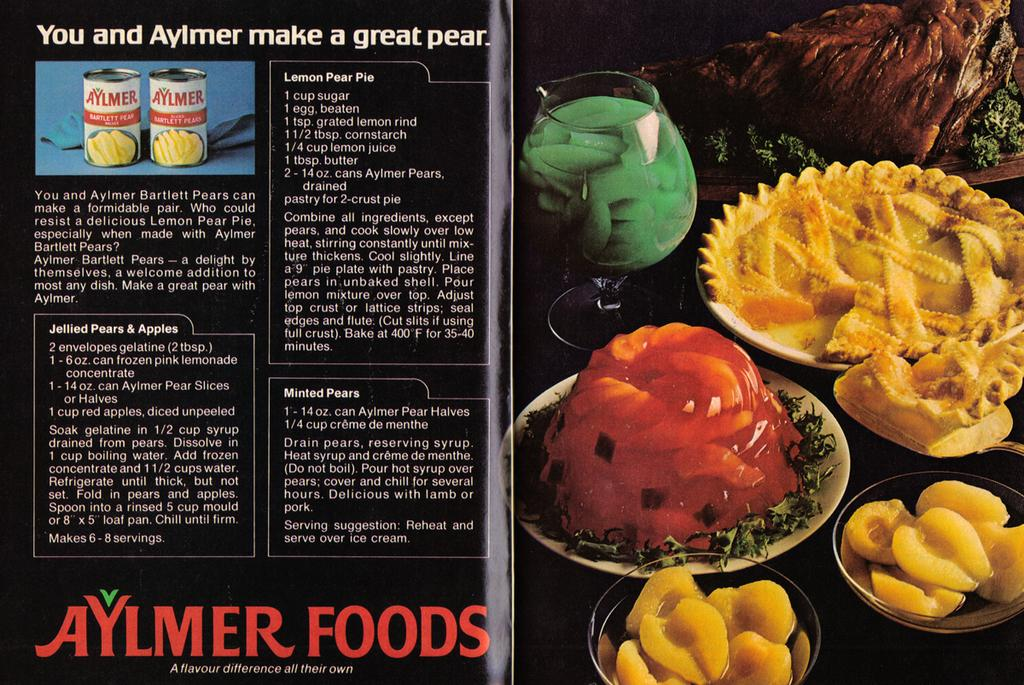What is the main object in the image? There is a flyer in the image. What type of content is on the flyer? The flyer contains food items. Is there any text on the flyer? Yes, there is text on the flyer. What type of spoon is used to serve the pie in the image? There is no spoon or pie present in the image; it only features a flyer with food items and text. 